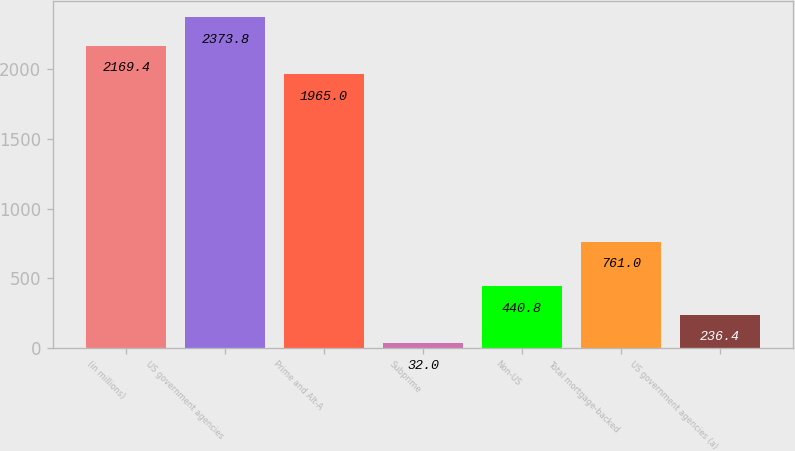Convert chart to OTSL. <chart><loc_0><loc_0><loc_500><loc_500><bar_chart><fcel>(in millions)<fcel>US government agencies<fcel>Prime and Alt-A<fcel>Subprime<fcel>Non-US<fcel>Total mortgage-backed<fcel>US government agencies (a)<nl><fcel>2169.4<fcel>2373.8<fcel>1965<fcel>32<fcel>440.8<fcel>761<fcel>236.4<nl></chart> 